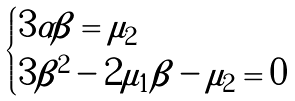Convert formula to latex. <formula><loc_0><loc_0><loc_500><loc_500>\begin{cases} 3 \alpha \beta = \mu _ { 2 } & \\ 3 \beta ^ { 2 } - 2 \mu _ { 1 } \beta - \mu _ { 2 } = 0 & \end{cases}</formula> 